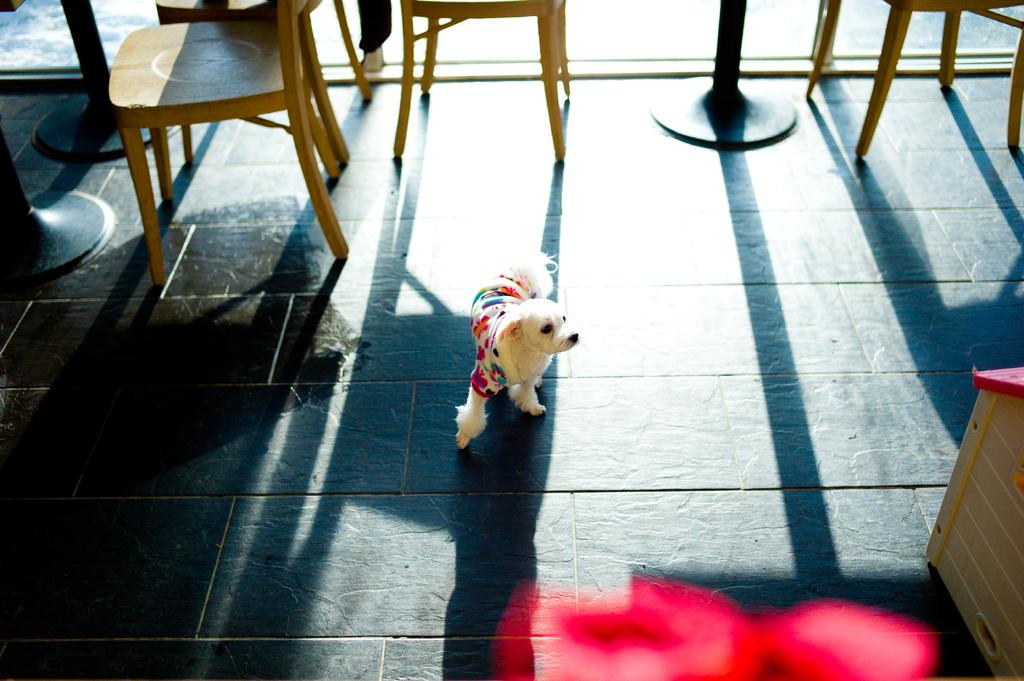What type of animal is in the image? There is a dog in the image. What is the dog wearing? The dog is wearing a dress. Where is the dog located in the image? The dog is on the floor. What can be seen in the background of the image? There are chairs and poles in the background of the image. How many toes can be seen on the dog's paws in the image? The image does not show the dog's paws, so it is not possible to determine the number of toes. 